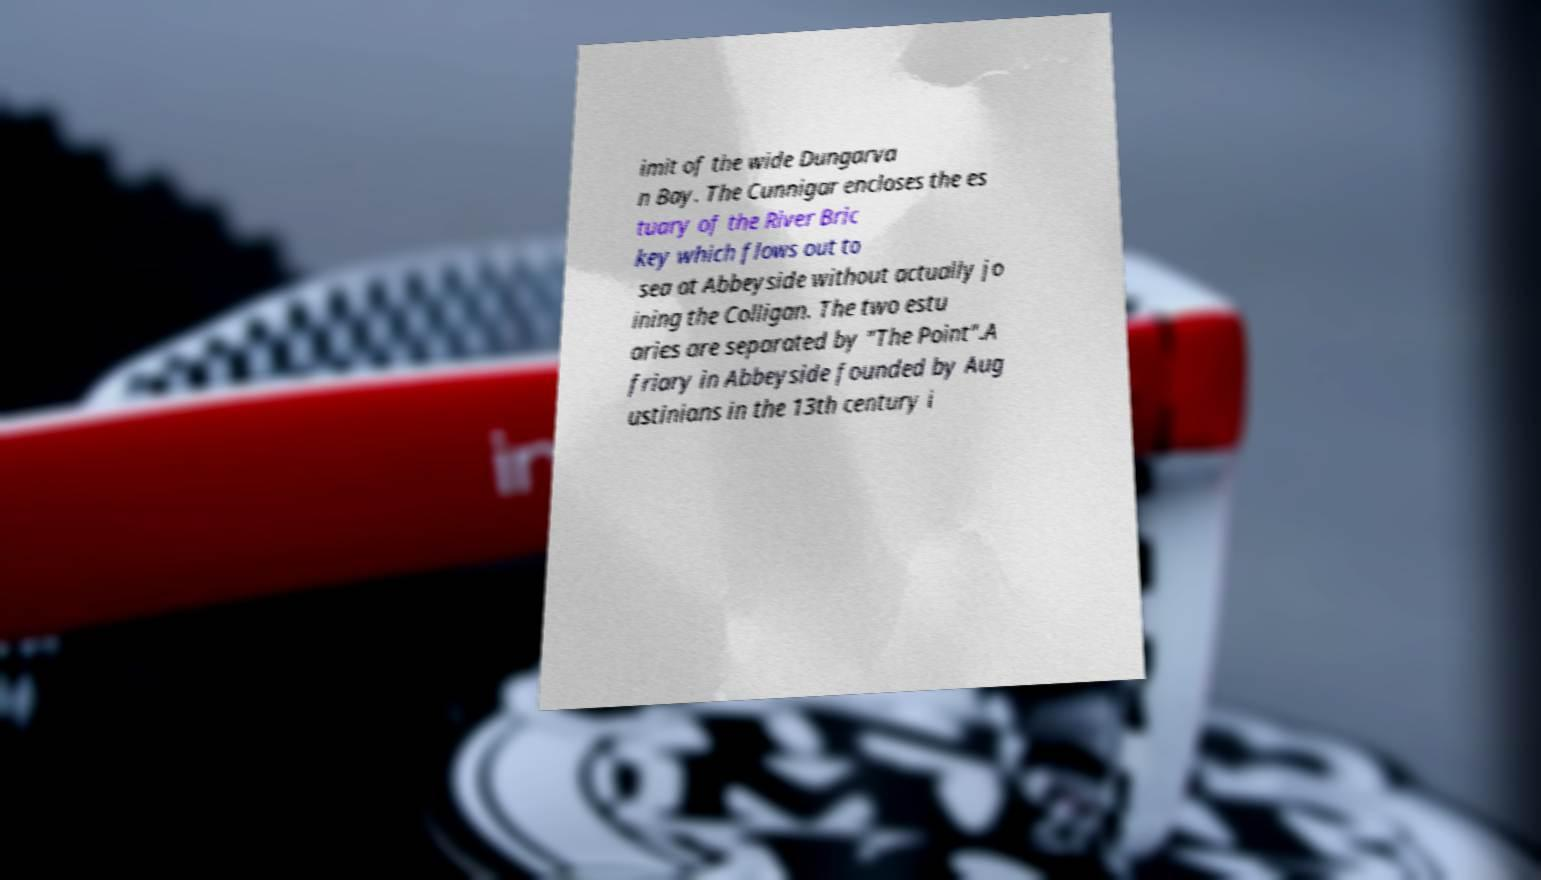Please read and relay the text visible in this image. What does it say? imit of the wide Dungarva n Bay. The Cunnigar encloses the es tuary of the River Bric key which flows out to sea at Abbeyside without actually jo ining the Colligan. The two estu aries are separated by "The Point".A friary in Abbeyside founded by Aug ustinians in the 13th century i 